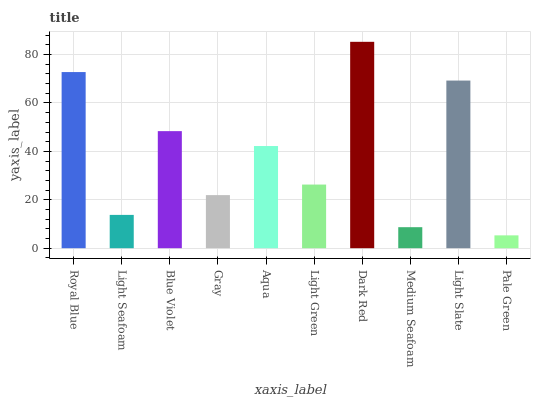Is Pale Green the minimum?
Answer yes or no. Yes. Is Dark Red the maximum?
Answer yes or no. Yes. Is Light Seafoam the minimum?
Answer yes or no. No. Is Light Seafoam the maximum?
Answer yes or no. No. Is Royal Blue greater than Light Seafoam?
Answer yes or no. Yes. Is Light Seafoam less than Royal Blue?
Answer yes or no. Yes. Is Light Seafoam greater than Royal Blue?
Answer yes or no. No. Is Royal Blue less than Light Seafoam?
Answer yes or no. No. Is Aqua the high median?
Answer yes or no. Yes. Is Light Green the low median?
Answer yes or no. Yes. Is Medium Seafoam the high median?
Answer yes or no. No. Is Royal Blue the low median?
Answer yes or no. No. 